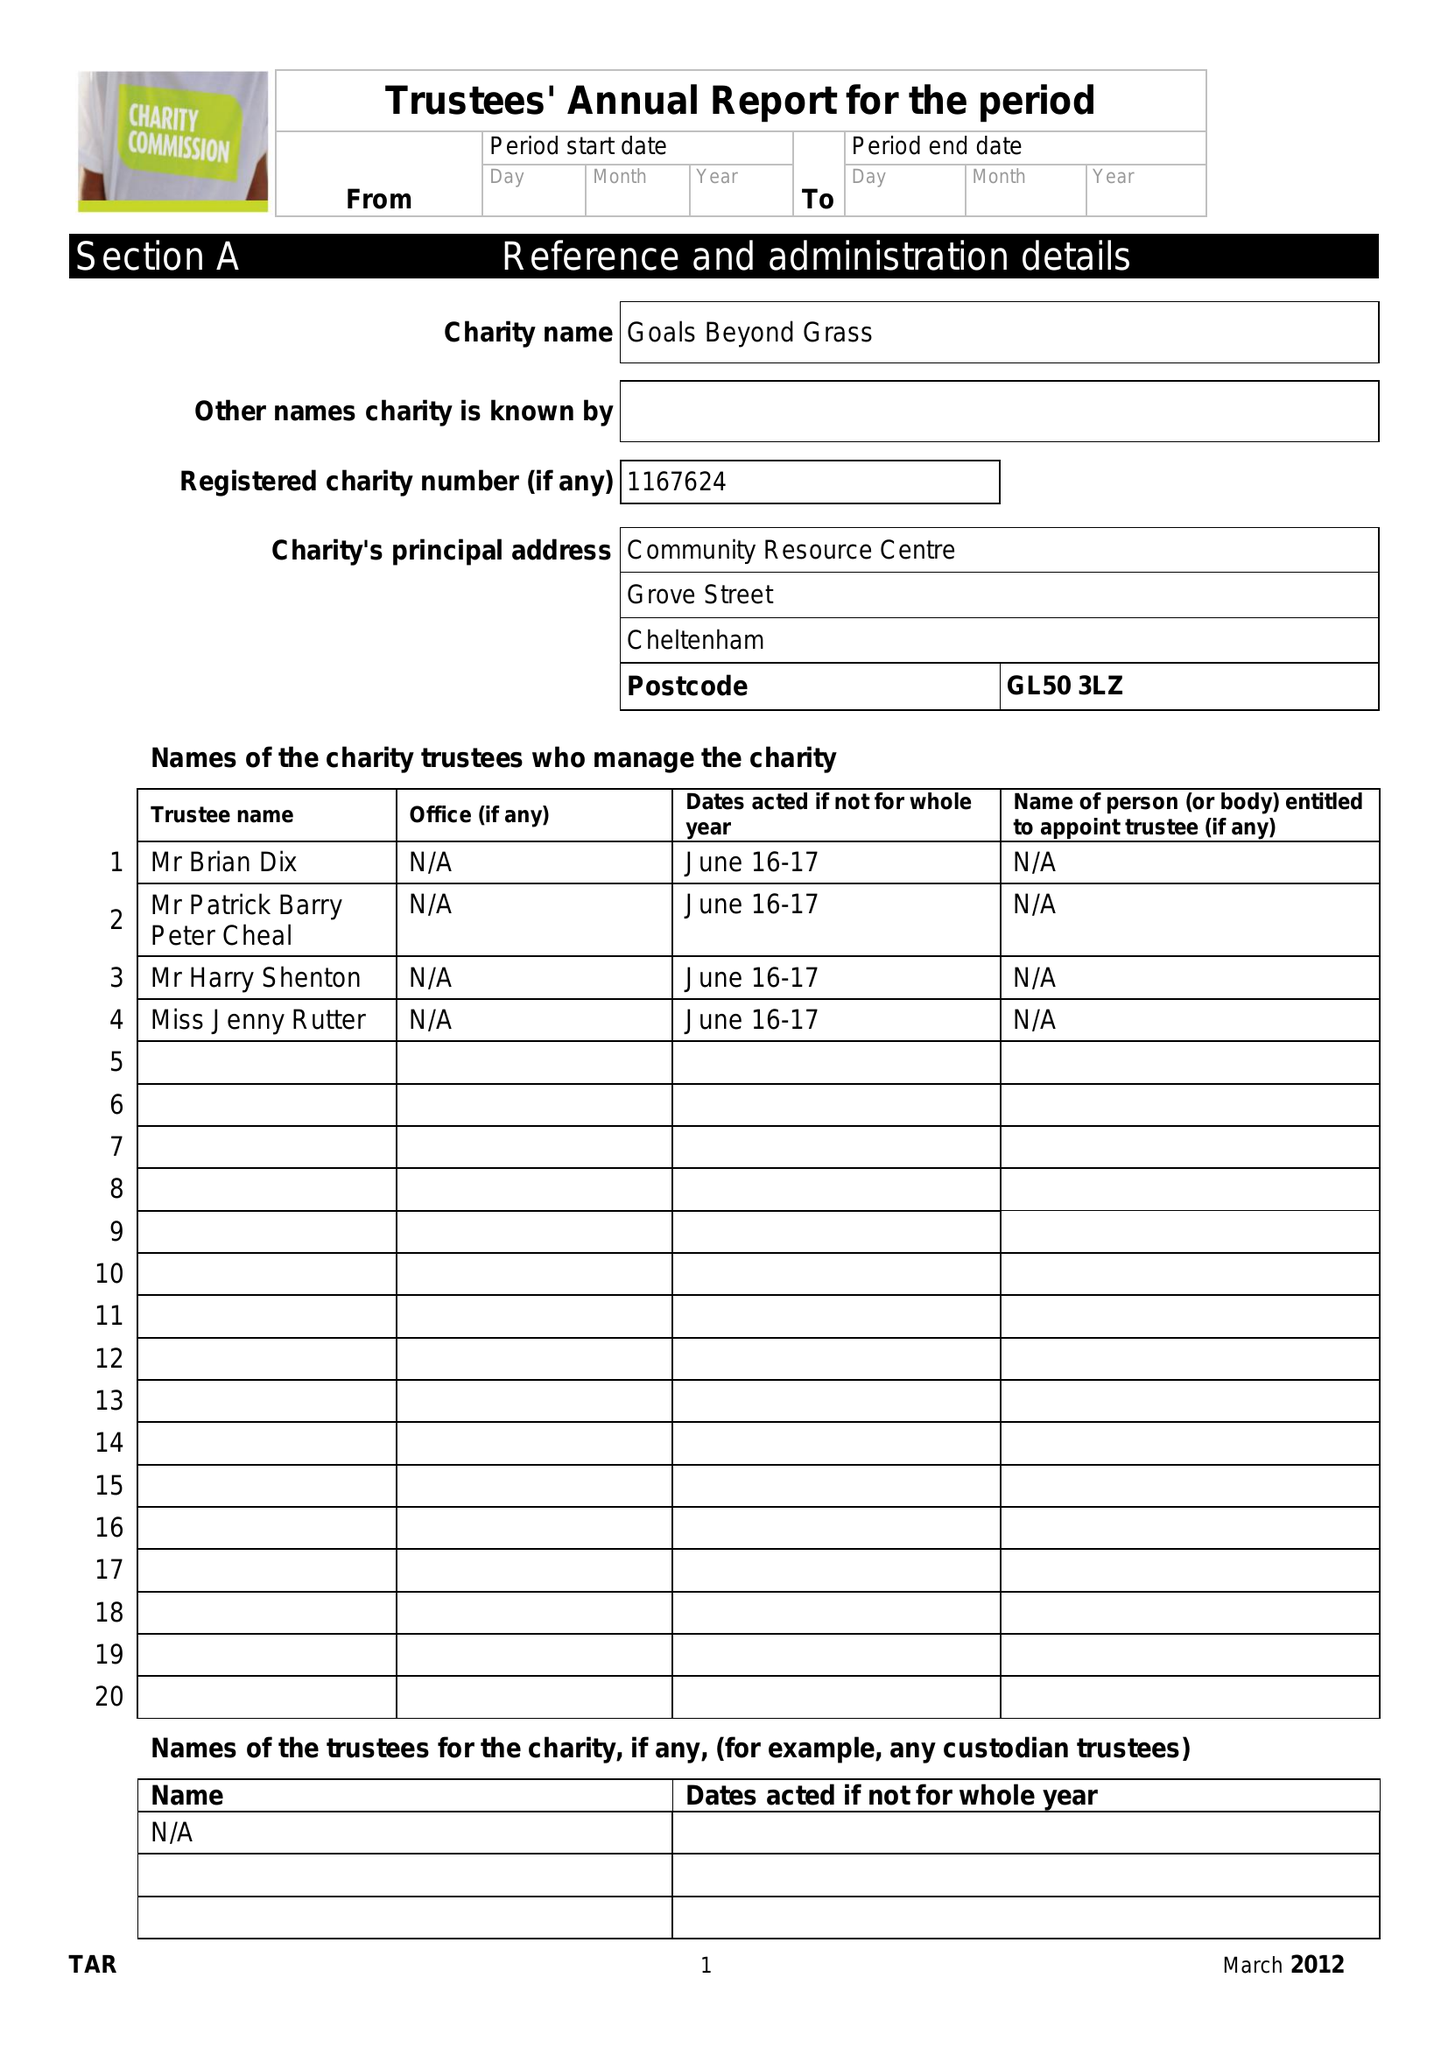What is the value for the address__post_town?
Answer the question using a single word or phrase. GLOUCESTER 